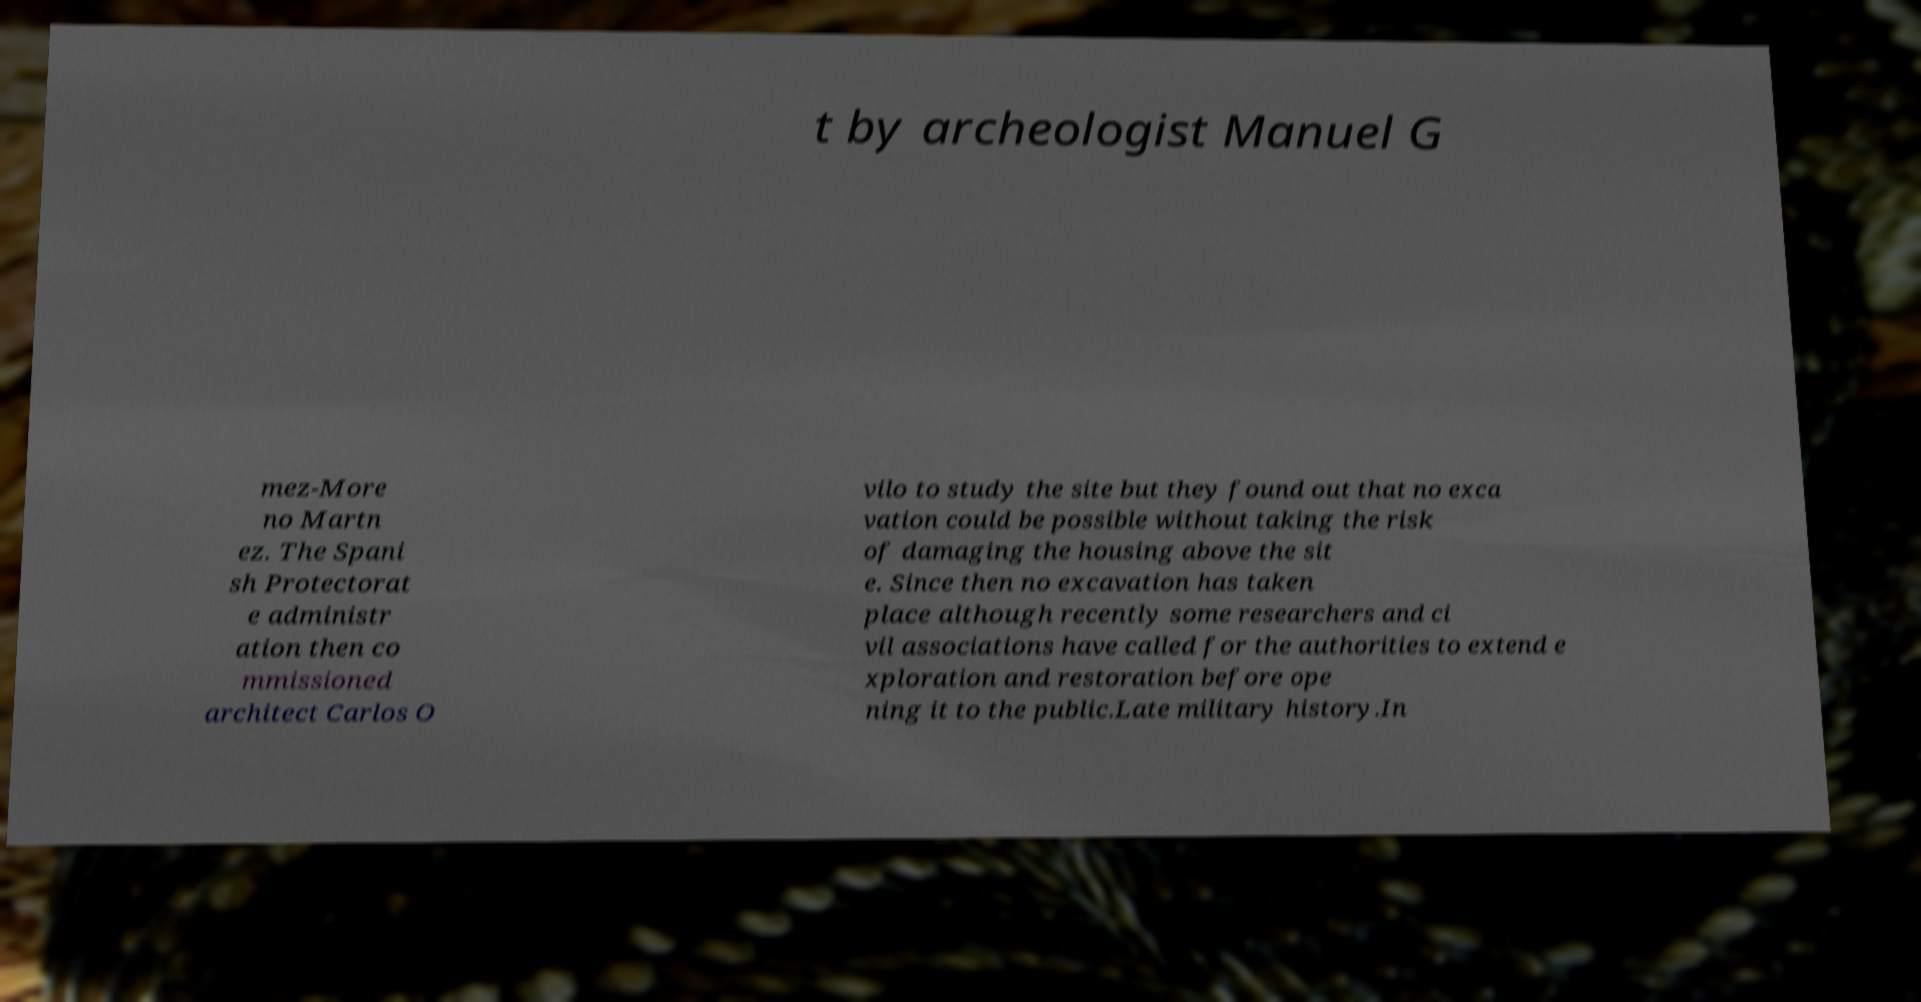For documentation purposes, I need the text within this image transcribed. Could you provide that? t by archeologist Manuel G mez-More no Martn ez. The Spani sh Protectorat e administr ation then co mmissioned architect Carlos O vilo to study the site but they found out that no exca vation could be possible without taking the risk of damaging the housing above the sit e. Since then no excavation has taken place although recently some researchers and ci vil associations have called for the authorities to extend e xploration and restoration before ope ning it to the public.Late military history.In 